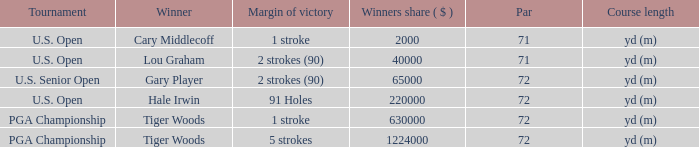What is the margin of victory when hale irwin wins? 91 Holes. 